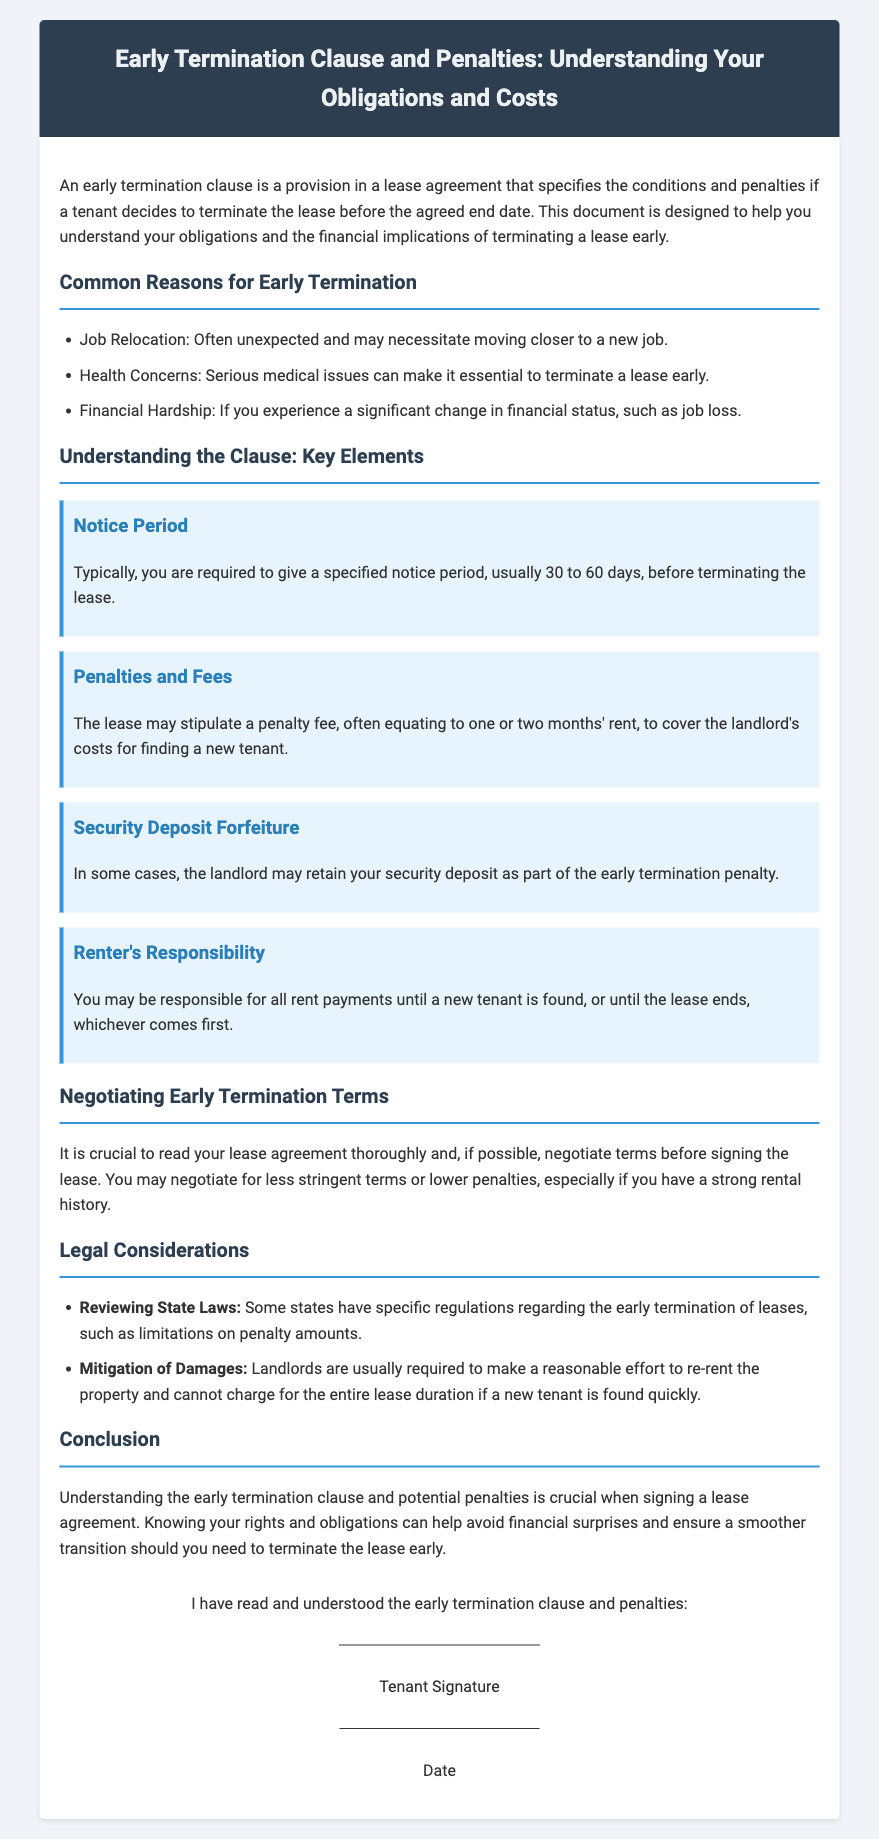What is an early termination clause? The early termination clause specifies the conditions and penalties if a tenant decides to terminate the lease before the agreed end date.
Answer: A provision in a lease agreement What is the typical notice period required? The document states that you are usually required to give a specified notice period before terminating the lease.
Answer: 30 to 60 days How much is the penalty fee for early termination? It mentions that the penalty fee often equates to one or two months' rent to cover the landlord's costs.
Answer: One or two months' rent What may the landlord retain as part of the early termination penalty? The document discusses what the landlord may keep as a penalty for early termination.
Answer: Security deposit What must landlords do regarding finding a new tenant? The legal considerations outline the requirement for landlords concerning new tenants after a lease termination.
Answer: Make a reasonable effort to re-rent the property What should you do before signing the lease? The document emphasizes the importance of a specific action related to the lease agreement.
Answer: Negotiate terms What are some common reasons for early termination listed? The content includes examples of situations that might lead to lease termination.
Answer: Job Relocation, Health Concerns, Financial Hardship What financial obligation might a tenant incur until a new tenant is found? The obligations discussed pertain to the financial responsibilities of the tenant after early termination.
Answer: Responsible for all rent payments until a new tenant is found 